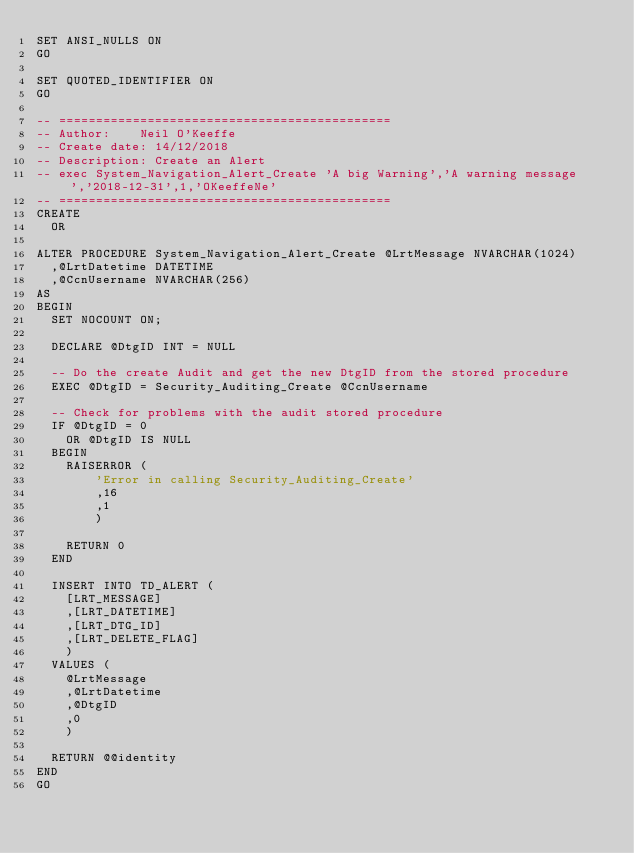<code> <loc_0><loc_0><loc_500><loc_500><_SQL_>SET ANSI_NULLS ON
GO

SET QUOTED_IDENTIFIER ON
GO

-- =============================================
-- Author:		Neil O'Keeffe
-- Create date: 14/12/2018
-- Description:	Create an Alert
-- exec System_Navigation_Alert_Create 'A big Warning','A warning message','2018-12-31',1,'OKeeffeNe'
-- =============================================
CREATE
	OR

ALTER PROCEDURE System_Navigation_Alert_Create @LrtMessage NVARCHAR(1024)
	,@LrtDatetime DATETIME
	,@CcnUsername NVARCHAR(256)
AS
BEGIN
	SET NOCOUNT ON;

	DECLARE @DtgID INT = NULL

	-- Do the create Audit and get the new DtgID from the stored procedure
	EXEC @DtgID = Security_Auditing_Create @CcnUsername

	-- Check for problems with the audit stored procedure
	IF @DtgID = 0
		OR @DtgID IS NULL
	BEGIN
		RAISERROR (
				'Error in calling Security_Auditing_Create'
				,16
				,1
				)

		RETURN 0
	END

	INSERT INTO TD_ALERT (
		[LRT_MESSAGE]
		,[LRT_DATETIME]
		,[LRT_DTG_ID]
		,[LRT_DELETE_FLAG]
		)
	VALUES (
		@LrtMessage
		,@LrtDatetime
		,@DtgID
		,0
		)

	RETURN @@identity
END
GO


</code> 